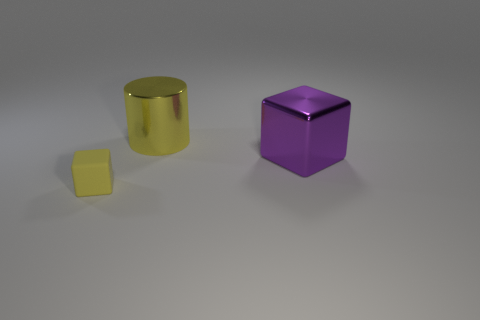How many shiny cylinders have the same color as the big shiny block?
Keep it short and to the point. 0. What is the shape of the purple thing that is made of the same material as the big yellow cylinder?
Keep it short and to the point. Cube. There is a metal object in front of the cylinder; what is its size?
Keep it short and to the point. Large. Are there the same number of purple objects in front of the metal block and big shiny objects that are to the left of the large yellow metallic cylinder?
Provide a short and direct response. Yes. There is a large metallic object that is in front of the yellow object that is behind the cube in front of the purple metal object; what color is it?
Offer a very short reply. Purple. How many metallic things are both on the right side of the big yellow metal cylinder and on the left side of the purple block?
Provide a short and direct response. 0. Do the large shiny thing behind the large purple metal cube and the cube that is in front of the big purple thing have the same color?
Offer a very short reply. Yes. Is there any other thing that is made of the same material as the cylinder?
Give a very brief answer. Yes. There is a purple object that is the same shape as the small yellow object; what is its size?
Your answer should be very brief. Large. Are there any big yellow shiny objects to the right of the big shiny cylinder?
Your answer should be very brief. No. 